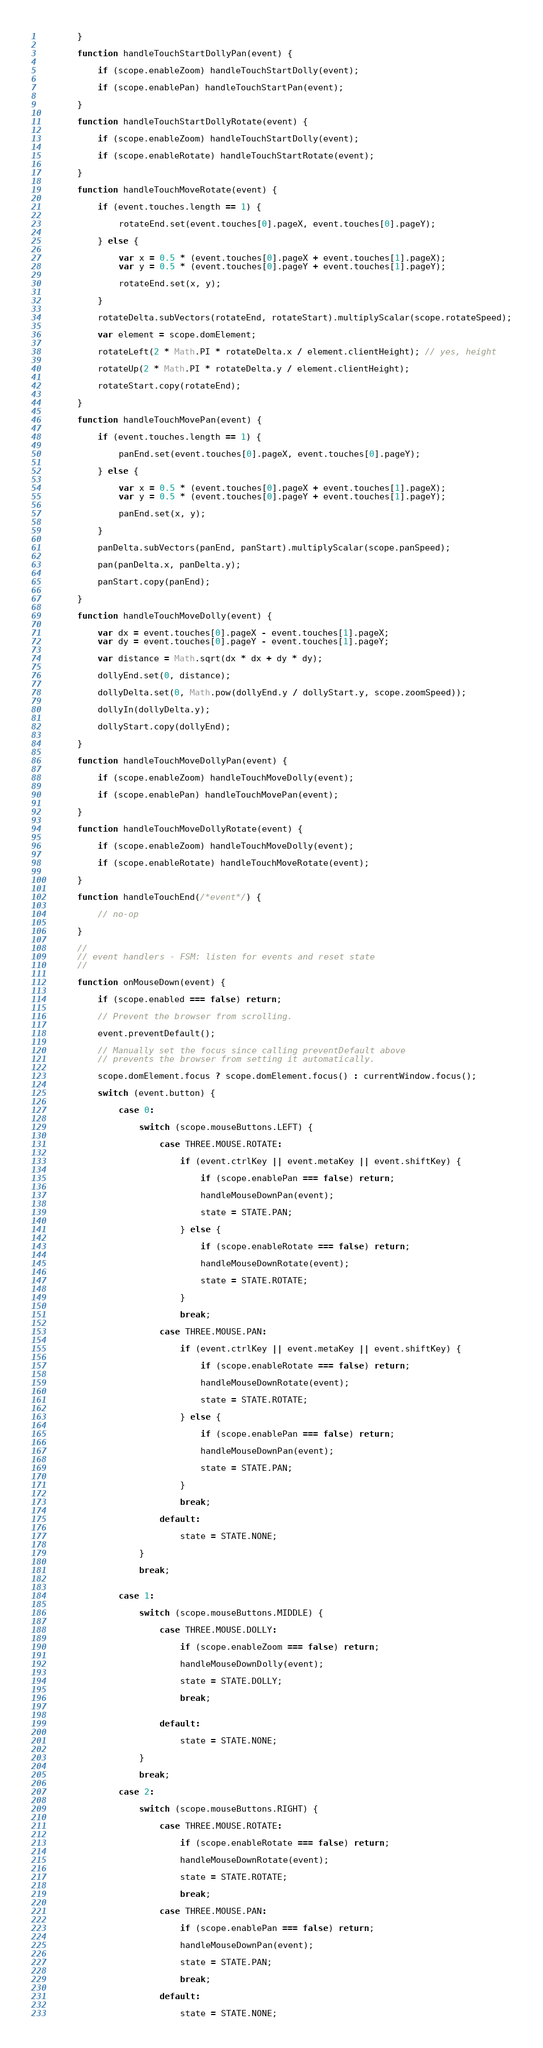<code> <loc_0><loc_0><loc_500><loc_500><_JavaScript_>        }

        function handleTouchStartDollyPan(event) {

            if (scope.enableZoom) handleTouchStartDolly(event);

            if (scope.enablePan) handleTouchStartPan(event);

        }

        function handleTouchStartDollyRotate(event) {

            if (scope.enableZoom) handleTouchStartDolly(event);

            if (scope.enableRotate) handleTouchStartRotate(event);

        }

        function handleTouchMoveRotate(event) {

            if (event.touches.length == 1) {

                rotateEnd.set(event.touches[0].pageX, event.touches[0].pageY);

            } else {

                var x = 0.5 * (event.touches[0].pageX + event.touches[1].pageX);
                var y = 0.5 * (event.touches[0].pageY + event.touches[1].pageY);

                rotateEnd.set(x, y);

            }

            rotateDelta.subVectors(rotateEnd, rotateStart).multiplyScalar(scope.rotateSpeed);

            var element = scope.domElement;

            rotateLeft(2 * Math.PI * rotateDelta.x / element.clientHeight); // yes, height

            rotateUp(2 * Math.PI * rotateDelta.y / element.clientHeight);

            rotateStart.copy(rotateEnd);

        }

        function handleTouchMovePan(event) {

            if (event.touches.length == 1) {

                panEnd.set(event.touches[0].pageX, event.touches[0].pageY);

            } else {

                var x = 0.5 * (event.touches[0].pageX + event.touches[1].pageX);
                var y = 0.5 * (event.touches[0].pageY + event.touches[1].pageY);

                panEnd.set(x, y);

            }

            panDelta.subVectors(panEnd, panStart).multiplyScalar(scope.panSpeed);

            pan(panDelta.x, panDelta.y);

            panStart.copy(panEnd);

        }

        function handleTouchMoveDolly(event) {

            var dx = event.touches[0].pageX - event.touches[1].pageX;
            var dy = event.touches[0].pageY - event.touches[1].pageY;

            var distance = Math.sqrt(dx * dx + dy * dy);

            dollyEnd.set(0, distance);

            dollyDelta.set(0, Math.pow(dollyEnd.y / dollyStart.y, scope.zoomSpeed));

            dollyIn(dollyDelta.y);

            dollyStart.copy(dollyEnd);

        }

        function handleTouchMoveDollyPan(event) {

            if (scope.enableZoom) handleTouchMoveDolly(event);

            if (scope.enablePan) handleTouchMovePan(event);

        }

        function handleTouchMoveDollyRotate(event) {

            if (scope.enableZoom) handleTouchMoveDolly(event);

            if (scope.enableRotate) handleTouchMoveRotate(event);

        }

        function handleTouchEnd(/*event*/) {

            // no-op

        }

        //
        // event handlers - FSM: listen for events and reset state
        //

        function onMouseDown(event) {

            if (scope.enabled === false) return;

            // Prevent the browser from scrolling.

            event.preventDefault();

            // Manually set the focus since calling preventDefault above
            // prevents the browser from setting it automatically.

            scope.domElement.focus ? scope.domElement.focus() : currentWindow.focus();

            switch (event.button) {

                case 0:

                    switch (scope.mouseButtons.LEFT) {

                        case THREE.MOUSE.ROTATE:

                            if (event.ctrlKey || event.metaKey || event.shiftKey) {

                                if (scope.enablePan === false) return;

                                handleMouseDownPan(event);

                                state = STATE.PAN;

                            } else {

                                if (scope.enableRotate === false) return;

                                handleMouseDownRotate(event);

                                state = STATE.ROTATE;

                            }

                            break;

                        case THREE.MOUSE.PAN:

                            if (event.ctrlKey || event.metaKey || event.shiftKey) {

                                if (scope.enableRotate === false) return;

                                handleMouseDownRotate(event);

                                state = STATE.ROTATE;

                            } else {

                                if (scope.enablePan === false) return;

                                handleMouseDownPan(event);

                                state = STATE.PAN;

                            }

                            break;

                        default:

                            state = STATE.NONE;

                    }

                    break;


                case 1:

                    switch (scope.mouseButtons.MIDDLE) {

                        case THREE.MOUSE.DOLLY:

                            if (scope.enableZoom === false) return;

                            handleMouseDownDolly(event);

                            state = STATE.DOLLY;

                            break;


                        default:

                            state = STATE.NONE;

                    }

                    break;

                case 2:

                    switch (scope.mouseButtons.RIGHT) {

                        case THREE.MOUSE.ROTATE:

                            if (scope.enableRotate === false) return;

                            handleMouseDownRotate(event);

                            state = STATE.ROTATE;

                            break;

                        case THREE.MOUSE.PAN:

                            if (scope.enablePan === false) return;

                            handleMouseDownPan(event);

                            state = STATE.PAN;

                            break;

                        default:

                            state = STATE.NONE;
</code> 